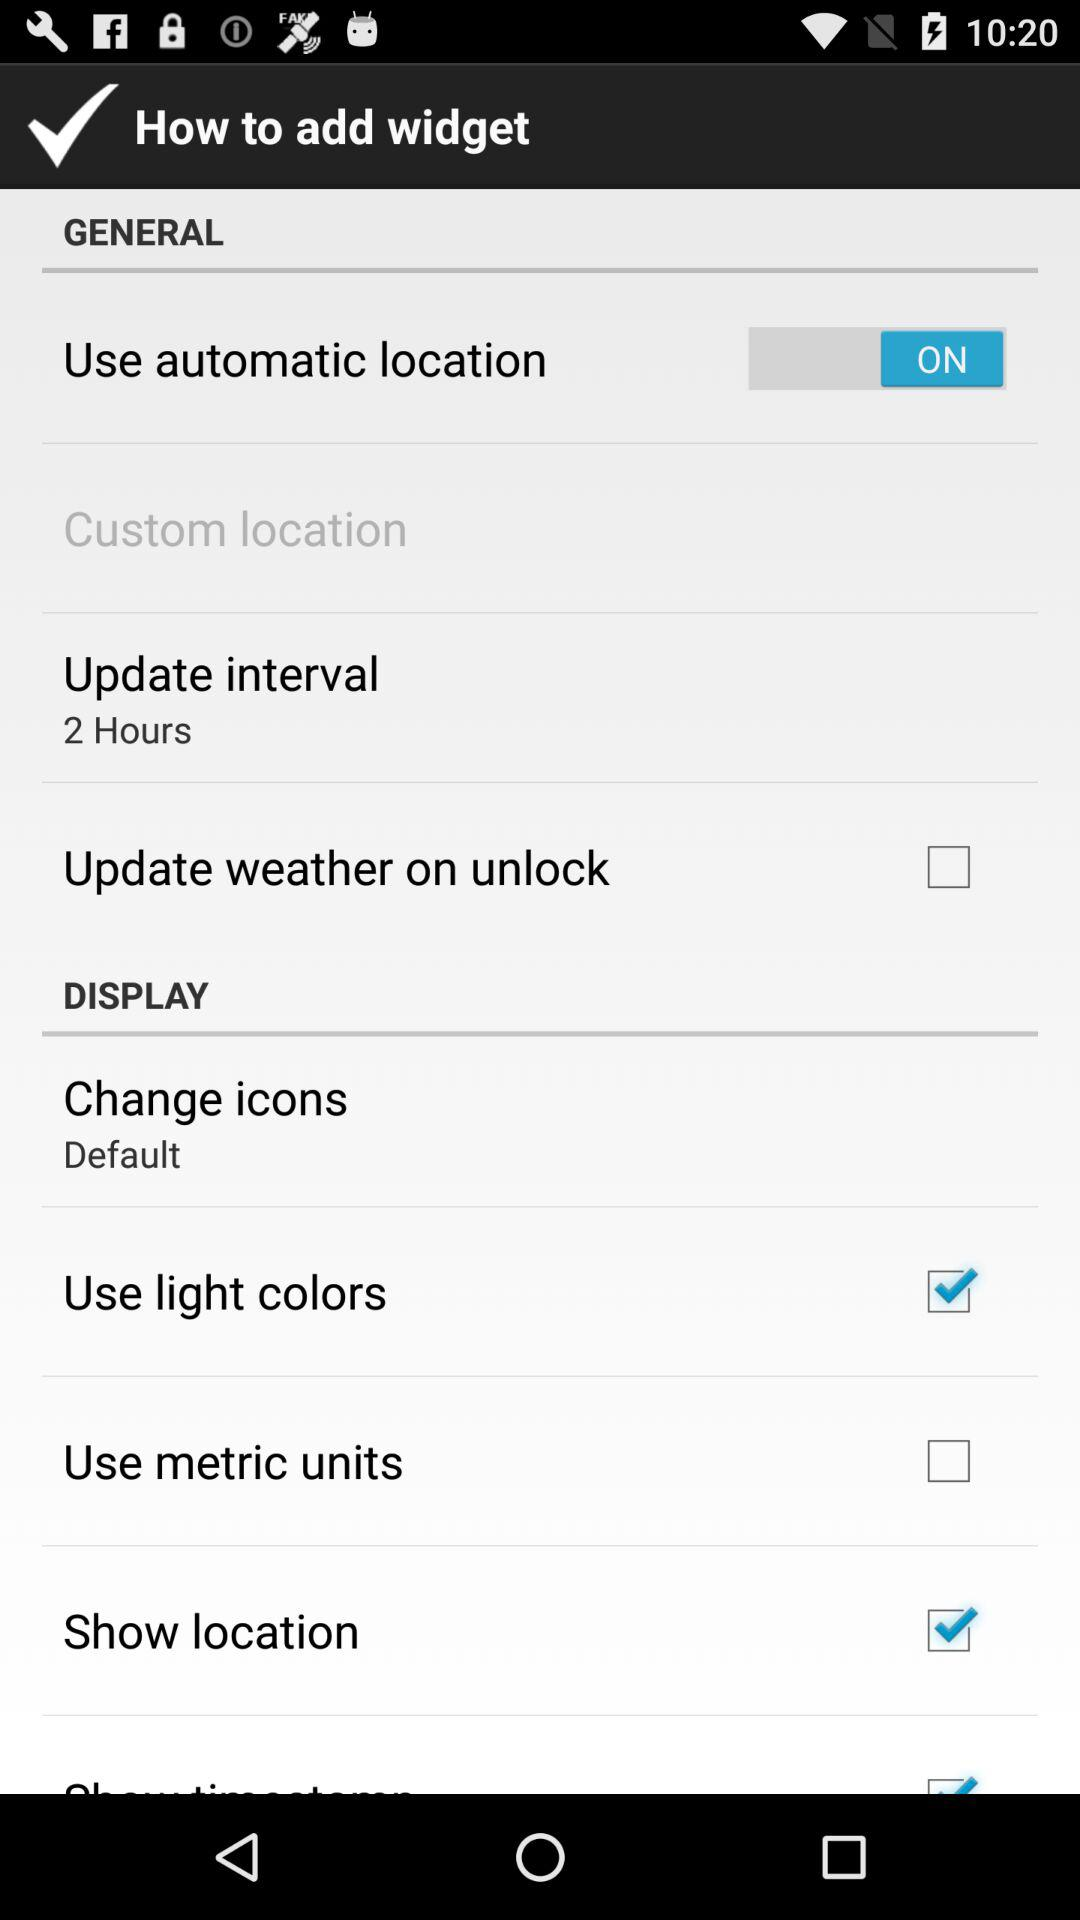What's the "Update interval"? The "Update interval" is 2 hours. 